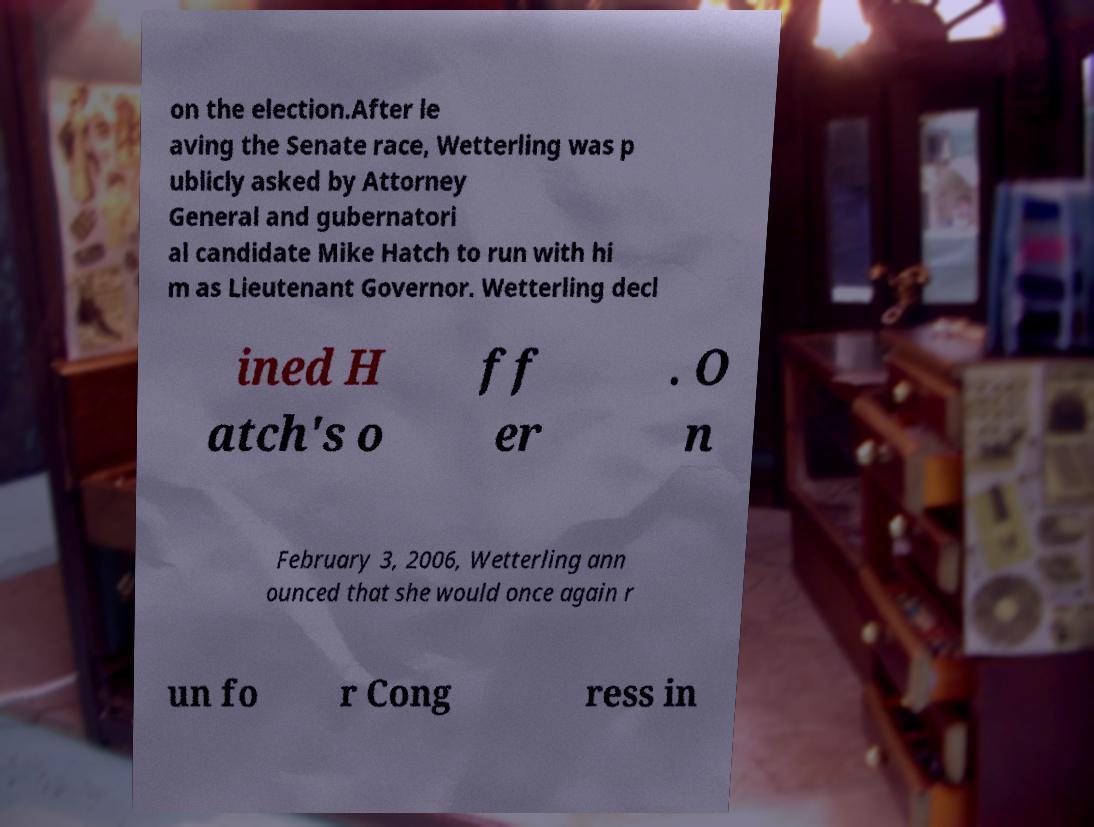Can you read and provide the text displayed in the image?This photo seems to have some interesting text. Can you extract and type it out for me? on the election.After le aving the Senate race, Wetterling was p ublicly asked by Attorney General and gubernatori al candidate Mike Hatch to run with hi m as Lieutenant Governor. Wetterling decl ined H atch's o ff er . O n February 3, 2006, Wetterling ann ounced that she would once again r un fo r Cong ress in 